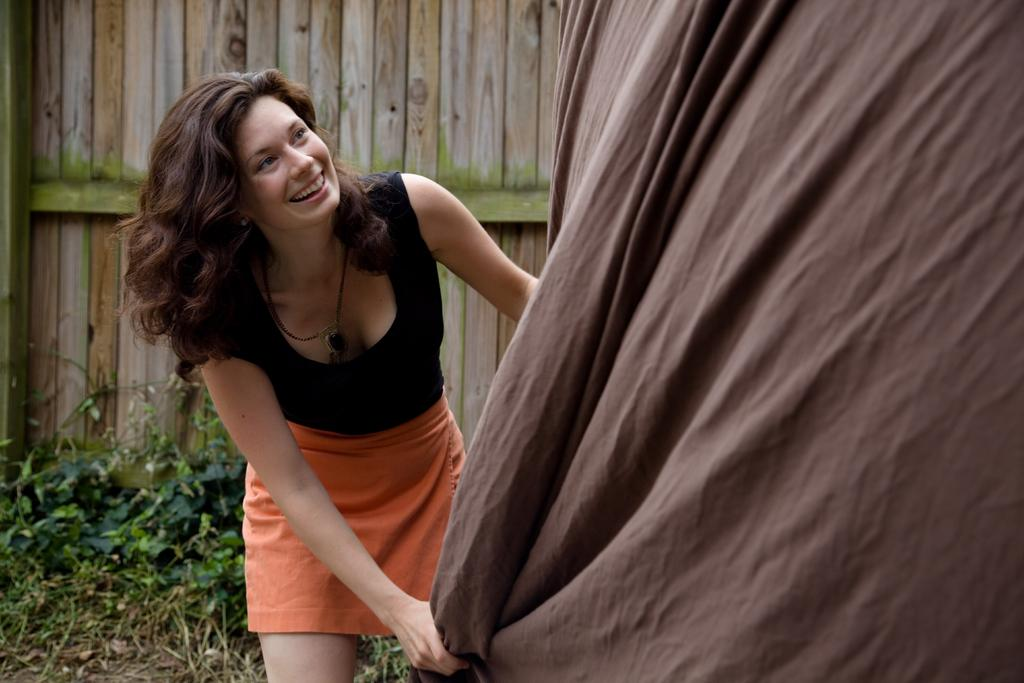Who is the main subject in the image? There is a lady in the center of the image. What can be seen in the background of the image? There is a wooden wall in the background of the image. Are there any natural elements present in the image? Yes, there are plants in the image. How many ducks are sitting on the stick in the image? There are no ducks or sticks present in the image. 